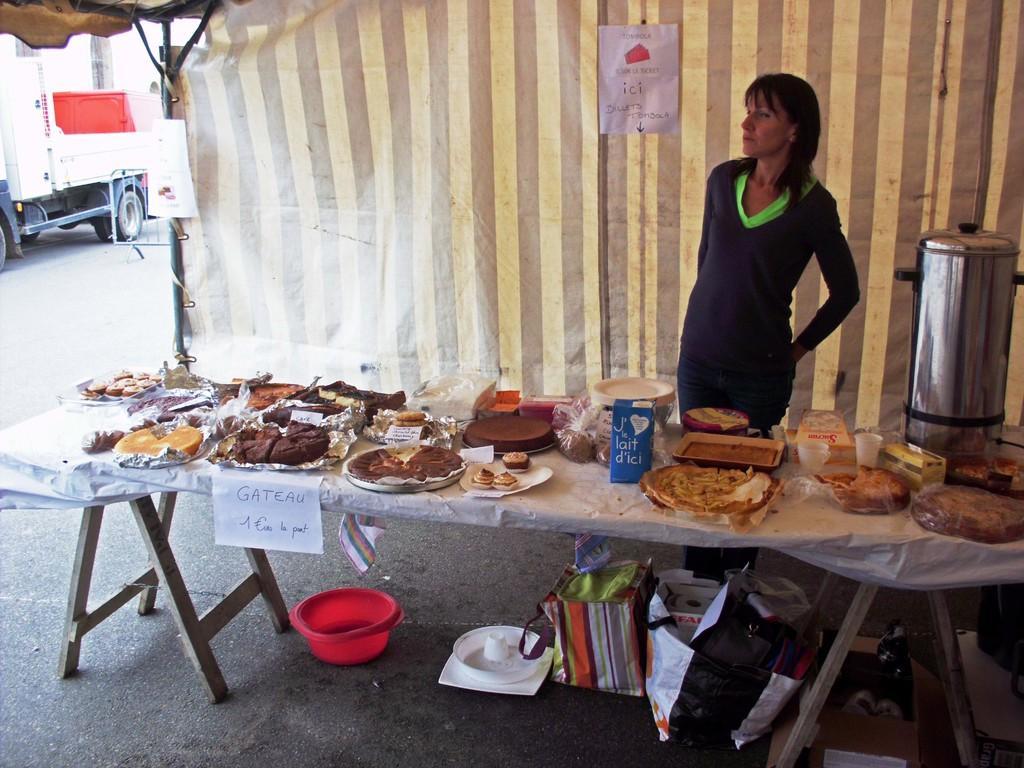Could you give a brief overview of what you see in this image? In this image in the center there is a table and on the table there is food and there is a woman standing and in the background there is a curtain and on the curtain there are posters with some text written on it. On the left side there is a vehicle and there is a building. 